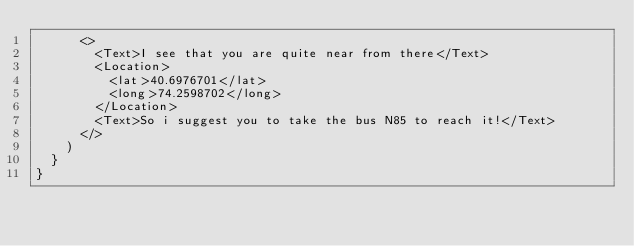Convert code to text. <code><loc_0><loc_0><loc_500><loc_500><_JavaScript_>      <>
        <Text>I see that you are quite near from there</Text>
        <Location>
          <lat>40.6976701</lat>
          <long>74.2598702</long>
        </Location>
        <Text>So i suggest you to take the bus N85 to reach it!</Text>
      </>
    )
  }
}
</code> 